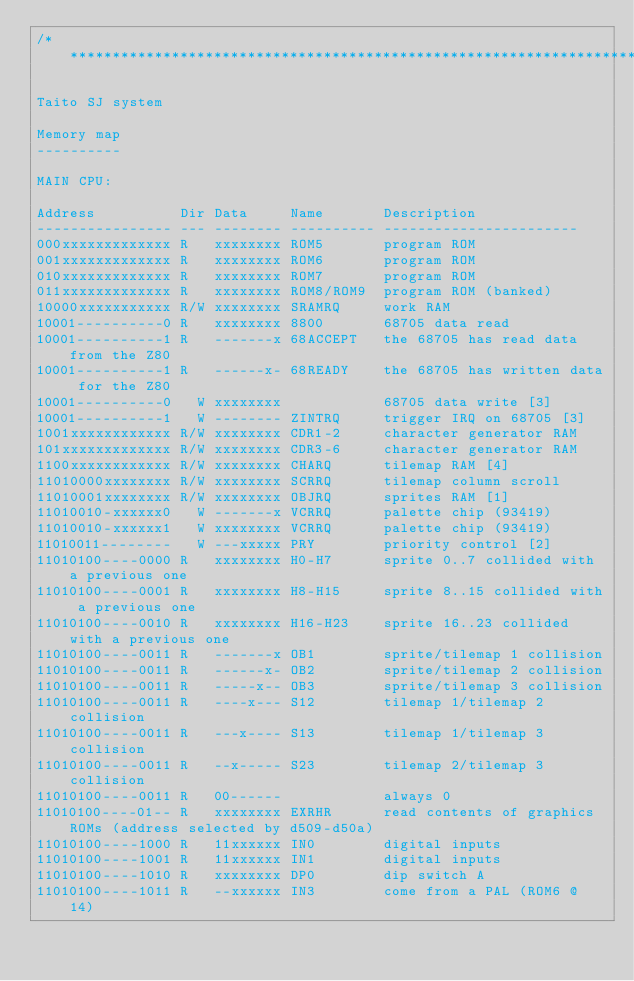Convert code to text. <code><loc_0><loc_0><loc_500><loc_500><_C_>/***************************************************************************

Taito SJ system

Memory map
----------

MAIN CPU:

Address          Dir Data     Name       Description
---------------- --- -------- ---------- -----------------------
000xxxxxxxxxxxxx R   xxxxxxxx ROM5       program ROM
001xxxxxxxxxxxxx R   xxxxxxxx ROM6       program ROM
010xxxxxxxxxxxxx R   xxxxxxxx ROM7       program ROM
011xxxxxxxxxxxxx R   xxxxxxxx ROM8/ROM9  program ROM (banked)
10000xxxxxxxxxxx R/W xxxxxxxx SRAMRQ     work RAM
10001----------0 R   xxxxxxxx 8800       68705 data read
10001----------1 R   -------x 68ACCEPT   the 68705 has read data from the Z80
10001----------1 R   ------x- 68READY    the 68705 has written data for the Z80
10001----------0   W xxxxxxxx            68705 data write [3]
10001----------1   W -------- ZINTRQ     trigger IRQ on 68705 [3]
1001xxxxxxxxxxxx R/W xxxxxxxx CDR1-2     character generator RAM
101xxxxxxxxxxxxx R/W xxxxxxxx CDR3-6     character generator RAM
1100xxxxxxxxxxxx R/W xxxxxxxx CHARQ      tilemap RAM [4]
11010000xxxxxxxx R/W xxxxxxxx SCRRQ      tilemap column scroll
11010001xxxxxxxx R/W xxxxxxxx OBJRQ      sprites RAM [1]
11010010-xxxxxx0   W -------x VCRRQ      palette chip (93419)
11010010-xxxxxx1   W xxxxxxxx VCRRQ      palette chip (93419)
11010011--------   W ---xxxxx PRY        priority control [2]
11010100----0000 R   xxxxxxxx H0-H7      sprite 0..7 collided with a previous one
11010100----0001 R   xxxxxxxx H8-H15     sprite 8..15 collided with a previous one
11010100----0010 R   xxxxxxxx H16-H23    sprite 16..23 collided with a previous one
11010100----0011 R   -------x OB1        sprite/tilemap 1 collision
11010100----0011 R   ------x- OB2        sprite/tilemap 2 collision
11010100----0011 R   -----x-- OB3        sprite/tilemap 3 collision
11010100----0011 R   ----x--- S12        tilemap 1/tilemap 2 collision
11010100----0011 R   ---x---- S13        tilemap 1/tilemap 3 collision
11010100----0011 R   --x----- S23        tilemap 2/tilemap 3 collision
11010100----0011 R   00------            always 0
11010100----01-- R   xxxxxxxx EXRHR      read contents of graphics ROMs (address selected by d509-d50a)
11010100----1000 R   11xxxxxx IN0        digital inputs
11010100----1001 R   11xxxxxx IN1        digital inputs
11010100----1010 R   xxxxxxxx DP0        dip switch A
11010100----1011 R   --xxxxxx IN3        come from a PAL (ROM6 @ 14)</code> 